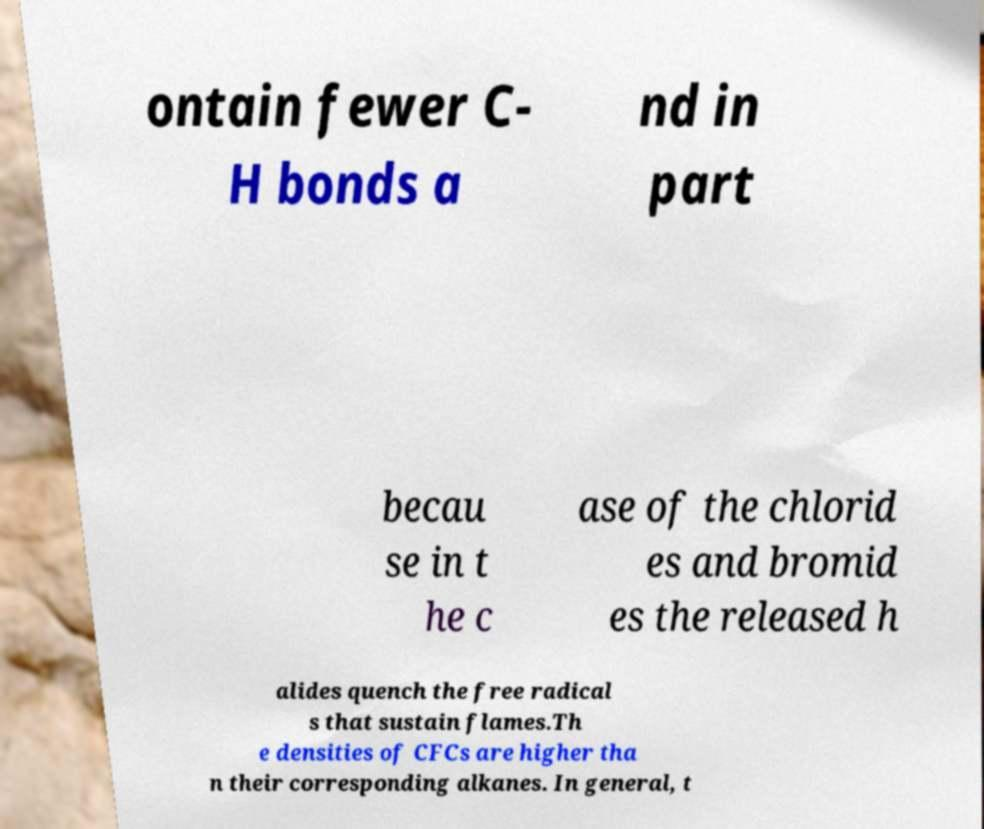There's text embedded in this image that I need extracted. Can you transcribe it verbatim? ontain fewer C- H bonds a nd in part becau se in t he c ase of the chlorid es and bromid es the released h alides quench the free radical s that sustain flames.Th e densities of CFCs are higher tha n their corresponding alkanes. In general, t 